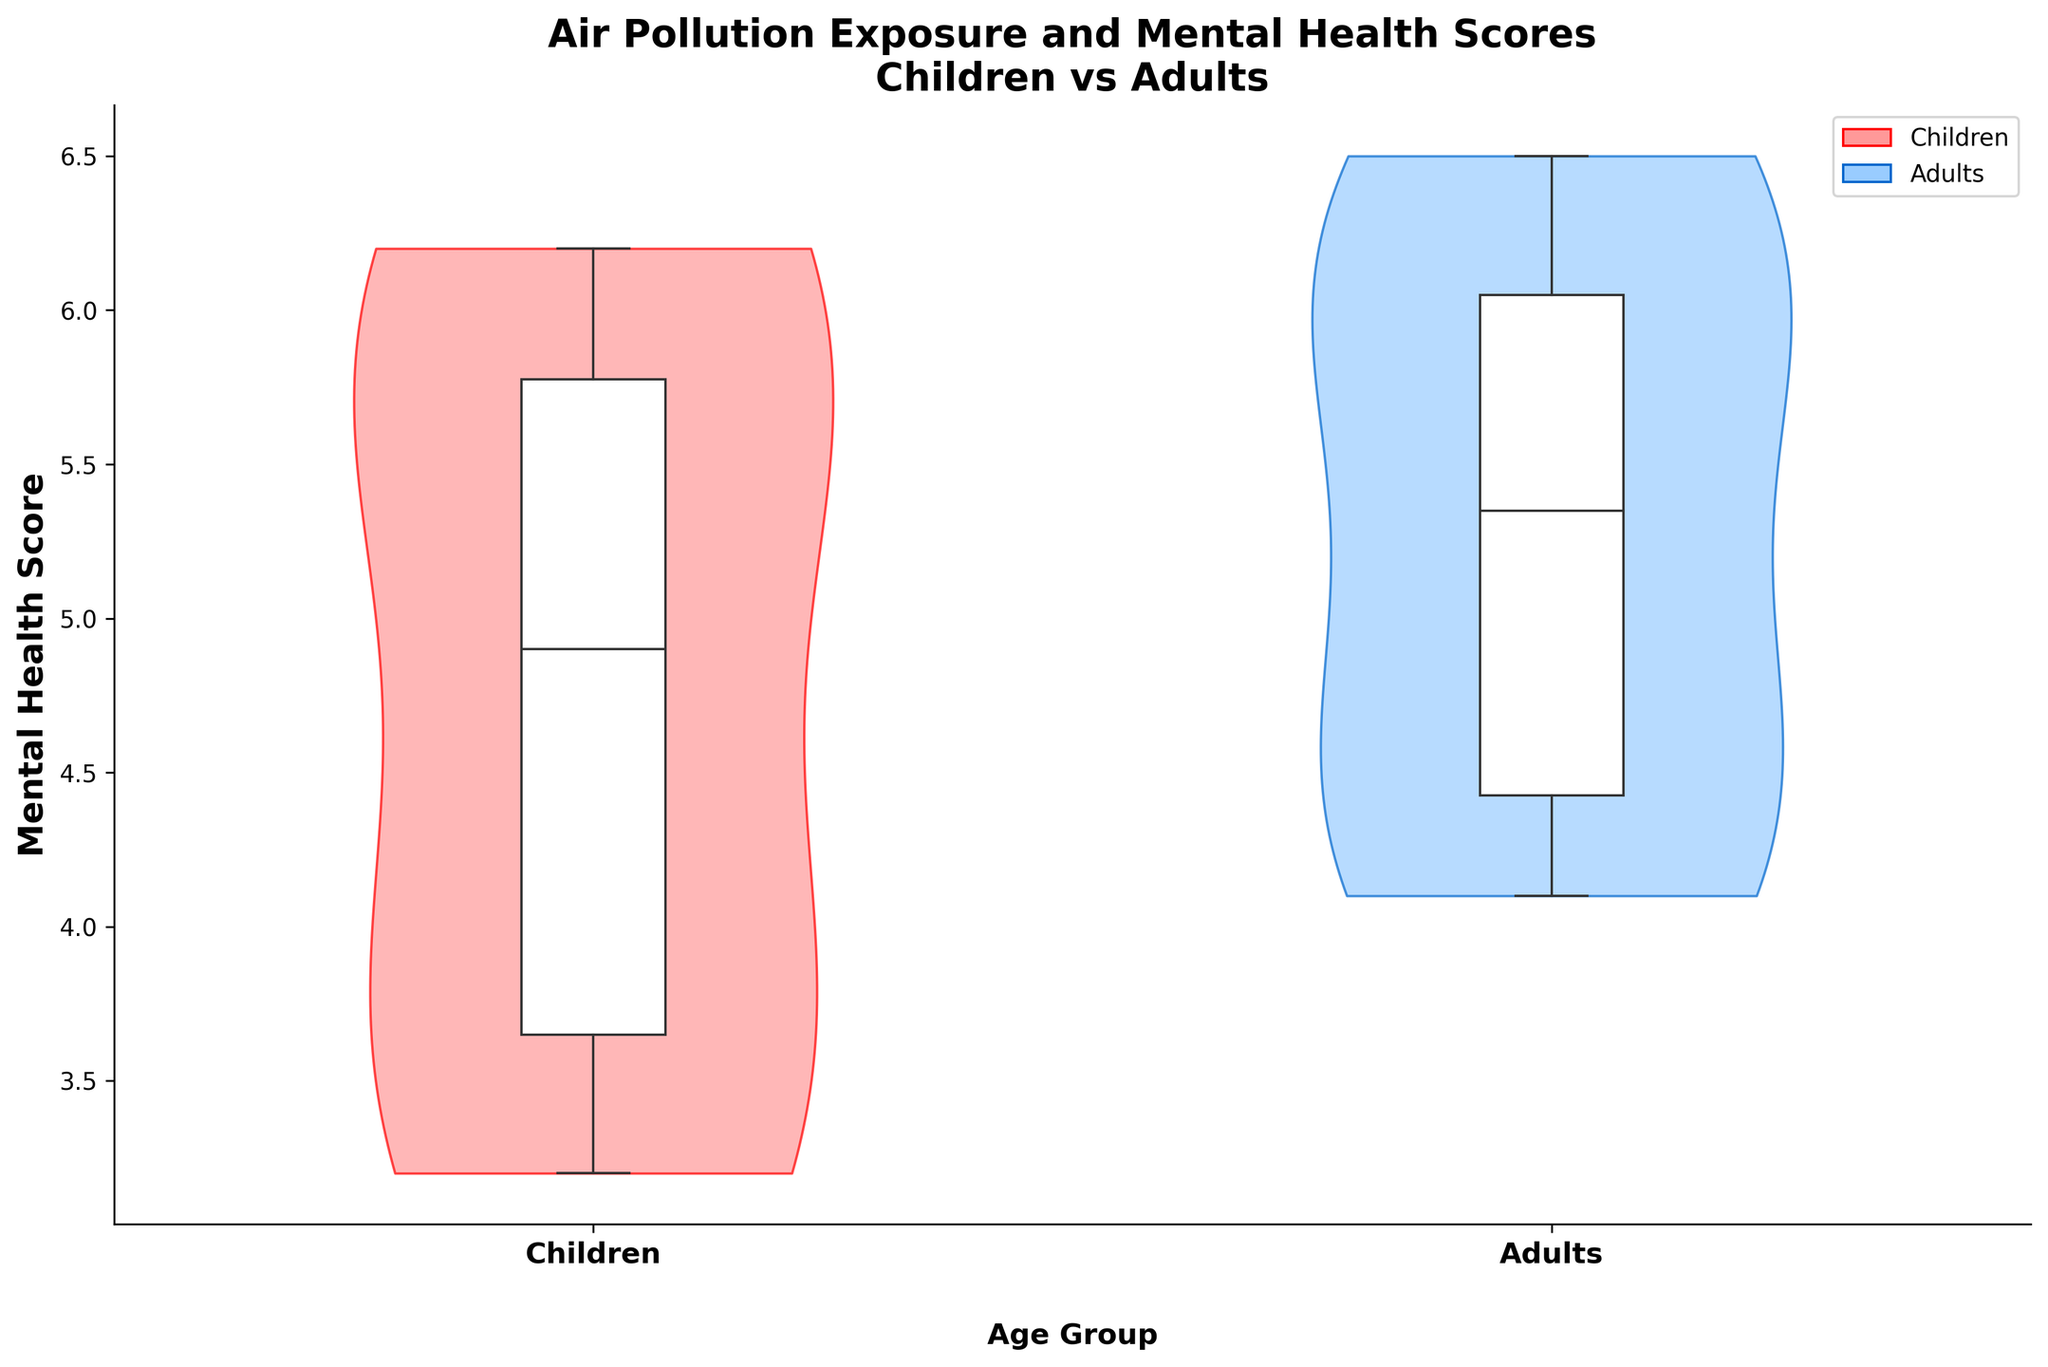What are the labels on the x-axis? The x-axis labels represent the two different age groups being compared in the study. They are specified directly under the x-axis.
Answer: Children and Adults What is the title of the plot? The title of the plot summarizes the relationship being examined between air pollution exposure and mental health scores for different age groups. It is found at the top of the plot.
Answer: Air Pollution Exposure and Mental Health Scores\nChildren vs Adults Which age group has the higher median mental health score? By observing the box plots within the violin plots, we can compare the line that marks the median in each category.
Answer: Adults How are the children's mental health scores distributed compared to the adults'? By looking at the distribution shapes (density) of the violin plots, we compare the spread and concentration of scores for both age groups. The children's plot is wider (indicating a larger spread) and slightly lower on average compared to the adults’.
Answer: The children's scores are more spread out and generally lower than the adults' Is there overlap in the interquartile ranges (IQRs) between children and adults? By examining the box plots inside the violins and comparing the upper and lower quartiles, we can see whether they share a common range.
Answer: Yes Which group shows more variability in mental health scores? Variability can be assessed by comparing the width and spread of the violin plots, where a wider spread indicates higher variability.
Answer: Children What's the difference in the lower boundary of the boxplot (i.e., first quartile) for children and adults? To find the difference, we compare the lower part of the box plots for both age groups and subtract the children's value from the adults'.
Answer: Approximately 1 (since the children’s lower quartile is around 3.5 and the adults’ is around 4.5) What colors are used to represent children and adults in the violin plot? The colors distinguish the two groups visually to aid in comparison. The legend in the upper right indicates the color coding.
Answer: Red for Children and Blue for Adults Which age group's distribution of mental health scores extends to a higher maximum value? By observing the violin plots' upper limit, we can see which group's scores reach a higher point.
Answer: Adults 